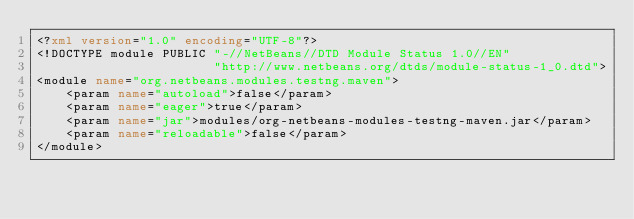<code> <loc_0><loc_0><loc_500><loc_500><_XML_><?xml version="1.0" encoding="UTF-8"?>
<!DOCTYPE module PUBLIC "-//NetBeans//DTD Module Status 1.0//EN"
                        "http://www.netbeans.org/dtds/module-status-1_0.dtd">
<module name="org.netbeans.modules.testng.maven">
    <param name="autoload">false</param>
    <param name="eager">true</param>
    <param name="jar">modules/org-netbeans-modules-testng-maven.jar</param>
    <param name="reloadable">false</param>
</module>
</code> 